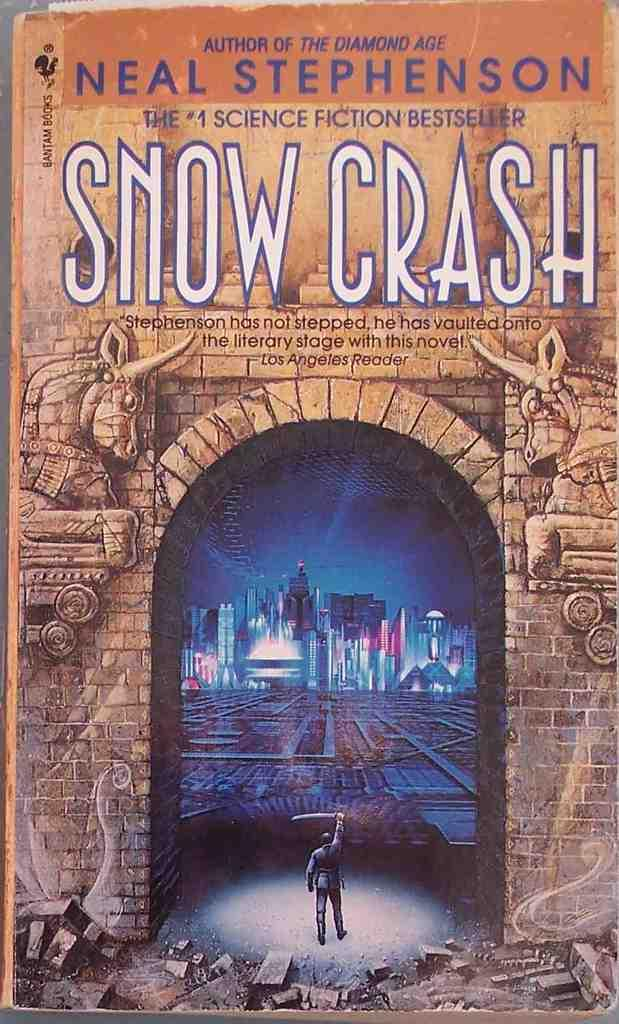Provide a one-sentence caption for the provided image. Book cover with a man holding a sword written by Neal Stephenson. 